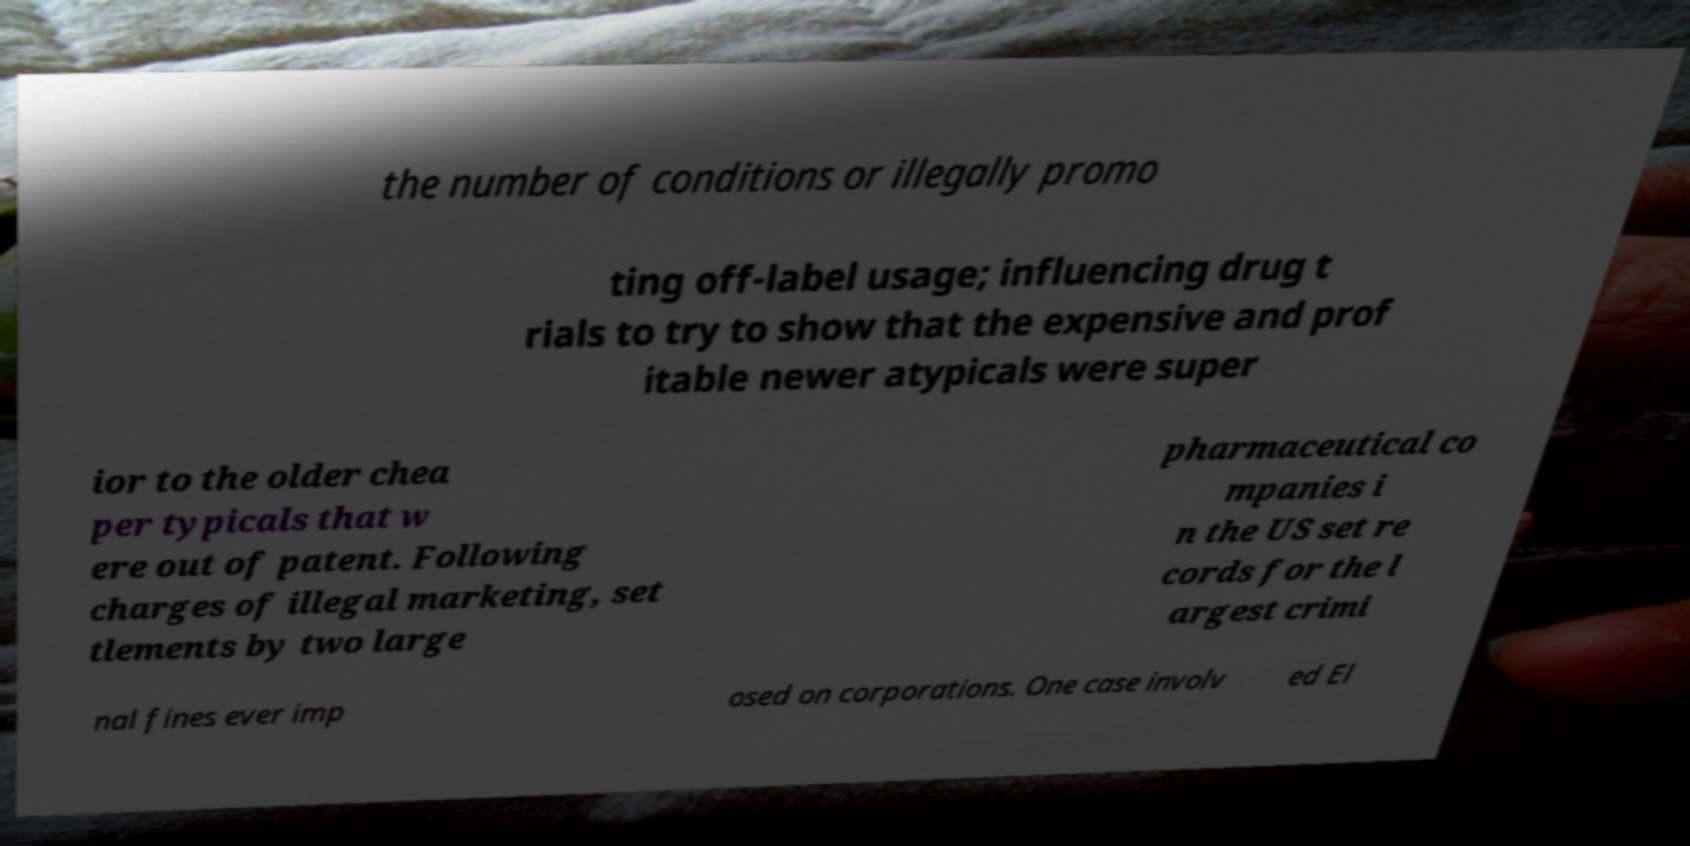Can you read and provide the text displayed in the image?This photo seems to have some interesting text. Can you extract and type it out for me? the number of conditions or illegally promo ting off-label usage; influencing drug t rials to try to show that the expensive and prof itable newer atypicals were super ior to the older chea per typicals that w ere out of patent. Following charges of illegal marketing, set tlements by two large pharmaceutical co mpanies i n the US set re cords for the l argest crimi nal fines ever imp osed on corporations. One case involv ed El 